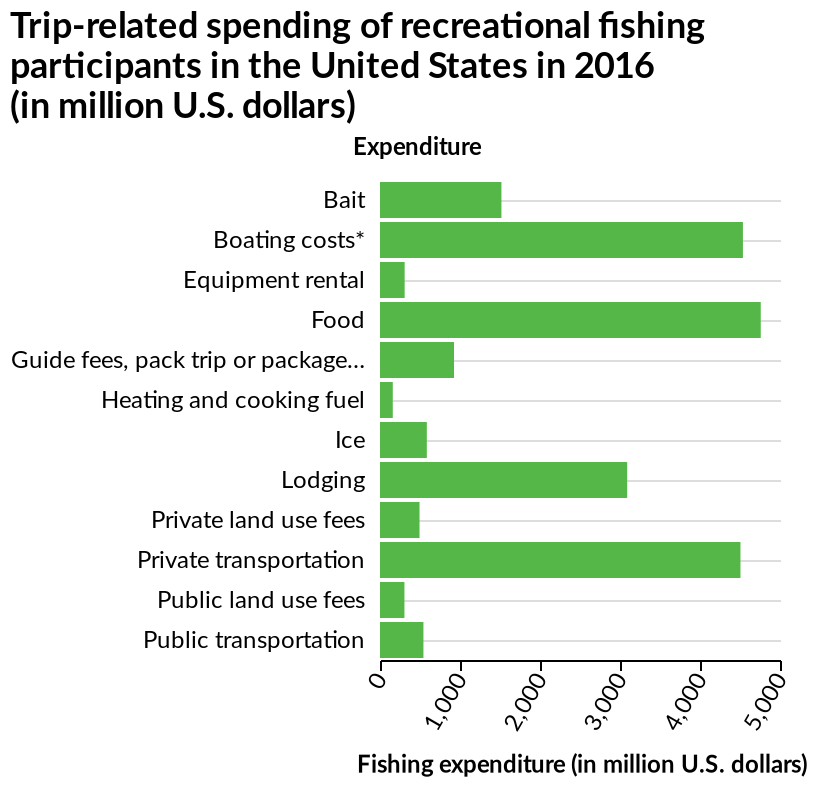<image>
What does the x-axis represent? The x-axis represents fishing expenditure in million U.S. dollars. How many expenditure subjects are much higher than the other categories?  4 expenditure subjects. What is the level of expenditure for food compared to other categories? Food has the highest expenditure out of all categories. What is the range of values on the x-axis? The range of values on the x-axis is from 0 to 5,000 (in million U.S. dollars). Describe the following image in detail Here a bar graph is named Trip-related spending of recreational fishing participants in the United States in 2016 (in million U.S. dollars). There is a linear scale with a minimum of 0 and a maximum of 5,000 along the x-axis, marked Fishing expenditure (in million U.S. dollars). A categorical scale from Bait to Public transportation can be found on the y-axis, marked Expenditure. 